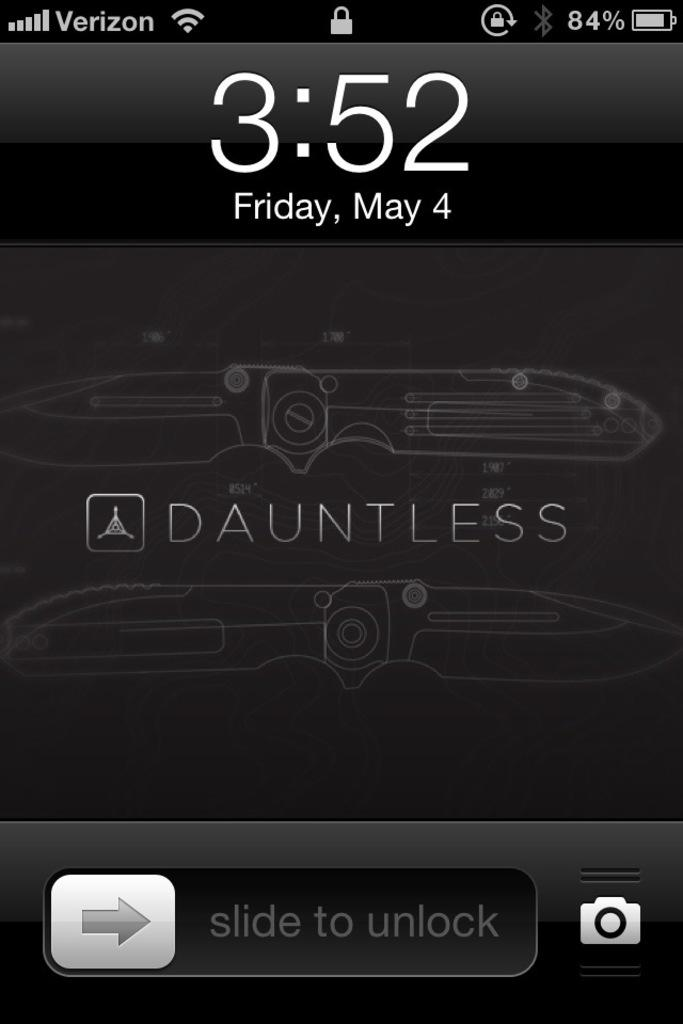<image>
Provide a brief description of the given image. A Verizon phone has the word Dauntless on it. 